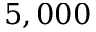<formula> <loc_0><loc_0><loc_500><loc_500>5 , 0 0 0</formula> 